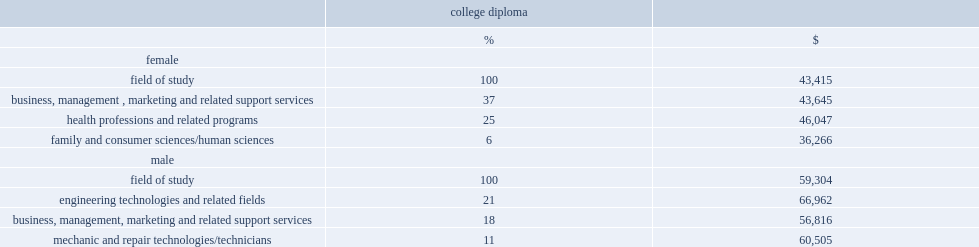What was the median employment income of male college diploma holders in engineering technology? 66962.0. What was the median employment income of female college diploma holders in business, management, marketing and related support services? 43645.0. What was the median income of female college graduates in business, management, marketing and related support services? 43645.0. What was the median income of male college graduates in business, management, marketing and related support services? 56816.0. Which gender college graduates had a higher median income in business, management, marketing and related support services? Male. What was the proportion of women with a college diploma in health and related fields? 25.0. What was the median income of women with a college diploma in health and related fields? 46047.0. What was the median cinome of women with a college diploma in all three fields of study? 43415.0. In which field of study, women with a college diploma were more likely to have a higher median income? Health professions and related programs. What was the median income of women with a college diploma in family and consumer sciences? 36266.0. 